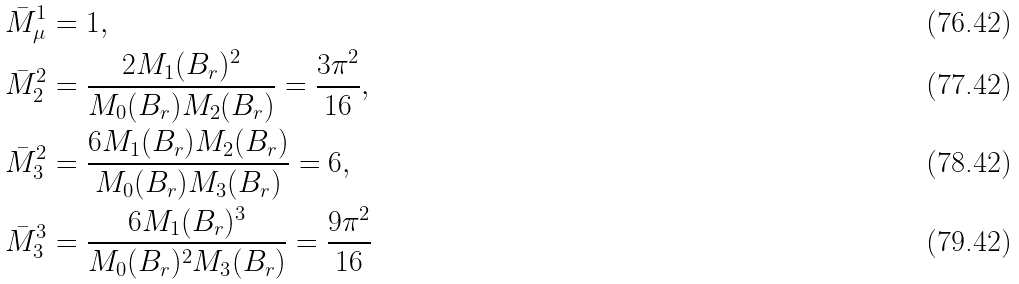Convert formula to latex. <formula><loc_0><loc_0><loc_500><loc_500>\bar { M } ^ { 1 } _ { \mu } & = 1 , \\ \bar { M } ^ { 2 } _ { 2 } & = \frac { 2 M _ { 1 } ( B _ { r } ) ^ { 2 } } { M _ { 0 } ( B _ { r } ) M _ { 2 } ( B _ { r } ) } = \frac { 3 \pi ^ { 2 } } { 1 6 } , \\ \bar { M } ^ { 2 } _ { 3 } & = \frac { 6 M _ { 1 } ( B _ { r } ) M _ { 2 } ( B _ { r } ) } { M _ { 0 } ( B _ { r } ) M _ { 3 } ( B _ { r } ) } = 6 , \\ \bar { M } ^ { 3 } _ { 3 } & = \frac { 6 M _ { 1 } ( B _ { r } ) ^ { 3 } } { M _ { 0 } ( B _ { r } ) ^ { 2 } M _ { 3 } ( B _ { r } ) } = \frac { 9 \pi ^ { 2 } } { 1 6 }</formula> 